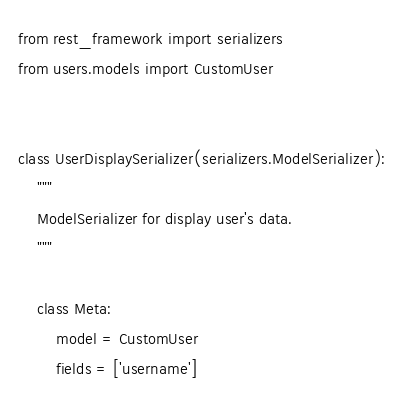<code> <loc_0><loc_0><loc_500><loc_500><_Python_>from rest_framework import serializers
from users.models import CustomUser


class UserDisplaySerializer(serializers.ModelSerializer):
    """
    ModelSerializer for display user's data.
    """

    class Meta:
        model = CustomUser
        fields = ['username']
</code> 